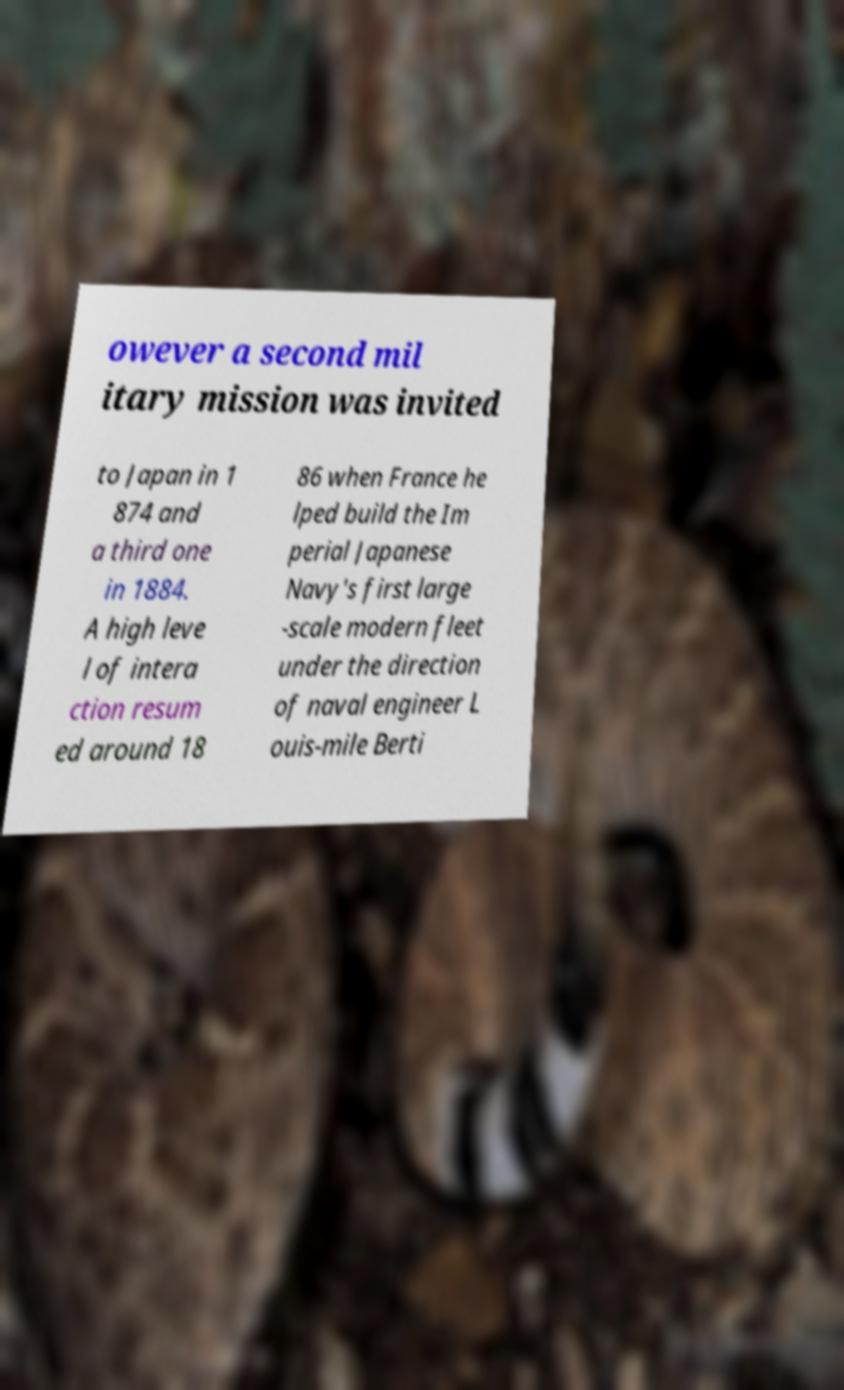There's text embedded in this image that I need extracted. Can you transcribe it verbatim? owever a second mil itary mission was invited to Japan in 1 874 and a third one in 1884. A high leve l of intera ction resum ed around 18 86 when France he lped build the Im perial Japanese Navy's first large -scale modern fleet under the direction of naval engineer L ouis-mile Berti 